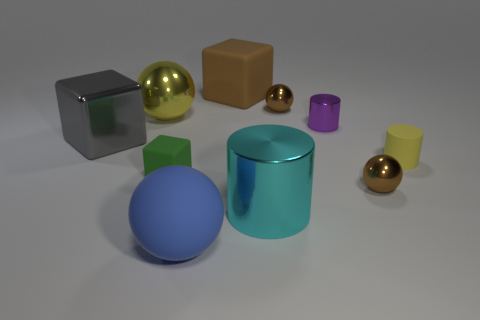Subtract all cubes. How many objects are left? 7 Subtract all tiny brown shiny balls. Subtract all small shiny things. How many objects are left? 5 Add 8 metallic cylinders. How many metallic cylinders are left? 10 Add 2 large purple rubber blocks. How many large purple rubber blocks exist? 2 Subtract 0 green cylinders. How many objects are left? 10 